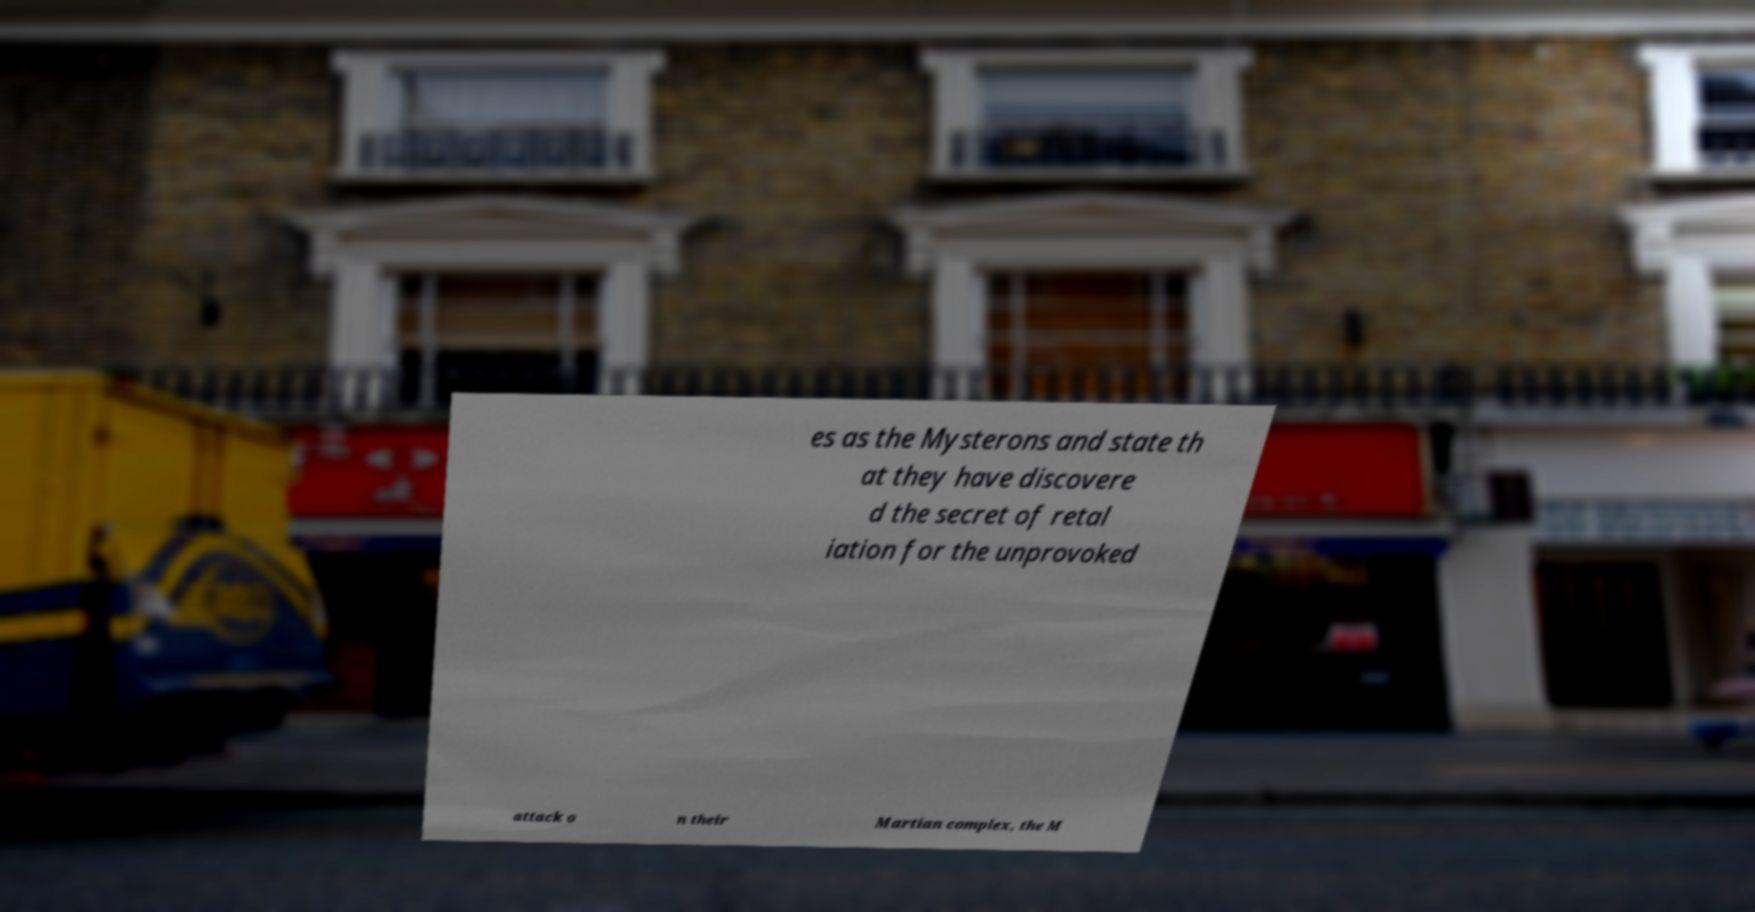I need the written content from this picture converted into text. Can you do that? es as the Mysterons and state th at they have discovere d the secret of retal iation for the unprovoked attack o n their Martian complex, the M 